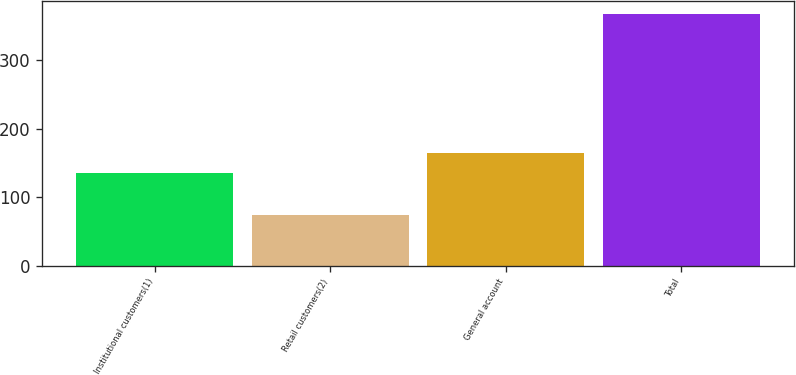Convert chart. <chart><loc_0><loc_0><loc_500><loc_500><bar_chart><fcel>Institutional customers(1)<fcel>Retail customers(2)<fcel>General account<fcel>Total<nl><fcel>134.7<fcel>73.5<fcel>164.09<fcel>367.4<nl></chart> 